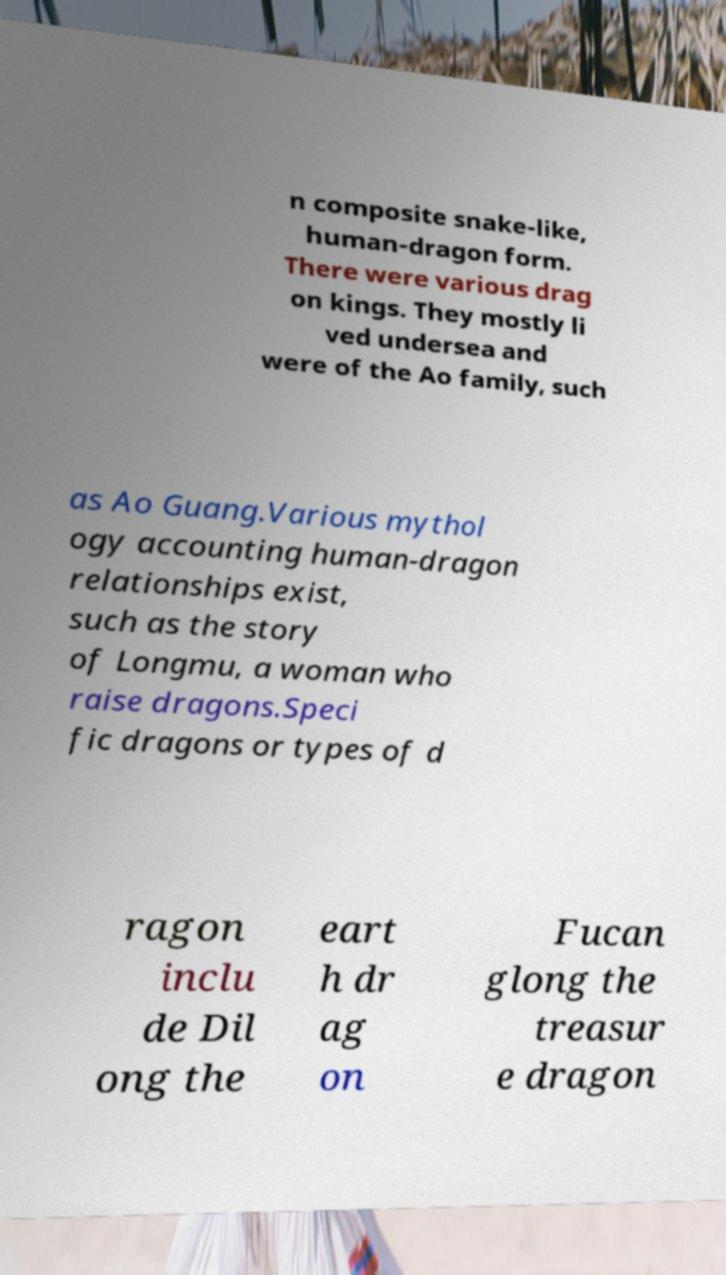I need the written content from this picture converted into text. Can you do that? n composite snake-like, human-dragon form. There were various drag on kings. They mostly li ved undersea and were of the Ao family, such as Ao Guang.Various mythol ogy accounting human-dragon relationships exist, such as the story of Longmu, a woman who raise dragons.Speci fic dragons or types of d ragon inclu de Dil ong the eart h dr ag on Fucan glong the treasur e dragon 